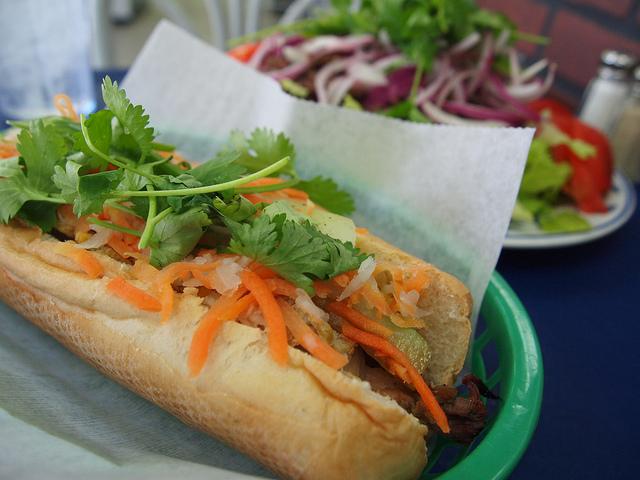What color is the plate?
Be succinct. White. What kind of herb is on top of the sandwich?
Answer briefly. Parsley. Is there any peppers on this sandwich?
Be succinct. No. 